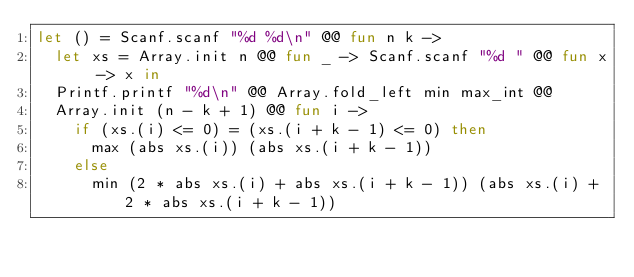Convert code to text. <code><loc_0><loc_0><loc_500><loc_500><_OCaml_>let () = Scanf.scanf "%d %d\n" @@ fun n k ->
  let xs = Array.init n @@ fun _ -> Scanf.scanf "%d " @@ fun x -> x in
  Printf.printf "%d\n" @@ Array.fold_left min max_int @@ 
  Array.init (n - k + 1) @@ fun i ->
    if (xs.(i) <= 0) = (xs.(i + k - 1) <= 0) then
      max (abs xs.(i)) (abs xs.(i + k - 1))
    else
      min (2 * abs xs.(i) + abs xs.(i + k - 1)) (abs xs.(i) + 2 * abs xs.(i + k - 1))

</code> 